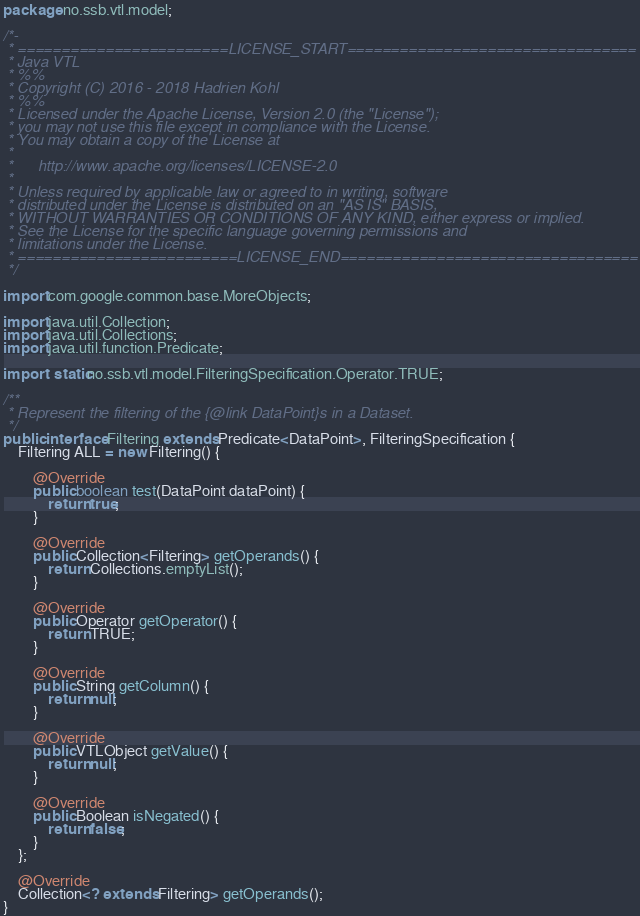Convert code to text. <code><loc_0><loc_0><loc_500><loc_500><_Java_>package no.ssb.vtl.model;

/*-
 * ========================LICENSE_START=================================
 * Java VTL
 * %%
 * Copyright (C) 2016 - 2018 Hadrien Kohl
 * %%
 * Licensed under the Apache License, Version 2.0 (the "License");
 * you may not use this file except in compliance with the License.
 * You may obtain a copy of the License at
 * 
 *      http://www.apache.org/licenses/LICENSE-2.0
 * 
 * Unless required by applicable law or agreed to in writing, software
 * distributed under the License is distributed on an "AS IS" BASIS,
 * WITHOUT WARRANTIES OR CONDITIONS OF ANY KIND, either express or implied.
 * See the License for the specific language governing permissions and
 * limitations under the License.
 * =========================LICENSE_END==================================
 */

import com.google.common.base.MoreObjects;

import java.util.Collection;
import java.util.Collections;
import java.util.function.Predicate;

import static no.ssb.vtl.model.FilteringSpecification.Operator.TRUE;

/**
 * Represent the filtering of the {@link DataPoint}s in a Dataset.
 */
public interface Filtering extends Predicate<DataPoint>, FilteringSpecification {
    Filtering ALL = new Filtering() {

        @Override
        public boolean test(DataPoint dataPoint) {
            return true;
        }

        @Override
        public Collection<Filtering> getOperands() {
            return Collections.emptyList();
        }

        @Override
        public Operator getOperator() {
            return TRUE;
        }

        @Override
        public String getColumn() {
            return null;
        }

        @Override
        public VTLObject getValue() {
            return null;
        }

        @Override
        public Boolean isNegated() {
            return false;
        }
    };

    @Override
    Collection<? extends Filtering> getOperands();
}
</code> 